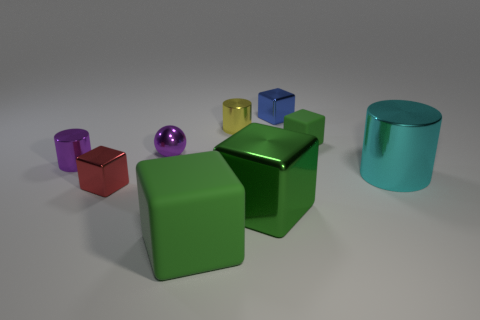Subtract all green cylinders. How many green blocks are left? 3 Subtract 1 cylinders. How many cylinders are left? 2 Subtract all tiny cubes. How many cubes are left? 2 Subtract all red cubes. How many cubes are left? 4 Subtract all brown cubes. Subtract all cyan cylinders. How many cubes are left? 5 Subtract all cylinders. How many objects are left? 6 Add 5 cyan cylinders. How many cyan cylinders are left? 6 Add 8 green shiny cubes. How many green shiny cubes exist? 9 Subtract 0 brown blocks. How many objects are left? 9 Subtract all brown metal blocks. Subtract all blue metal cubes. How many objects are left? 8 